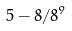<formula> <loc_0><loc_0><loc_500><loc_500>5 - 8 / 8 ^ { 9 }</formula> 